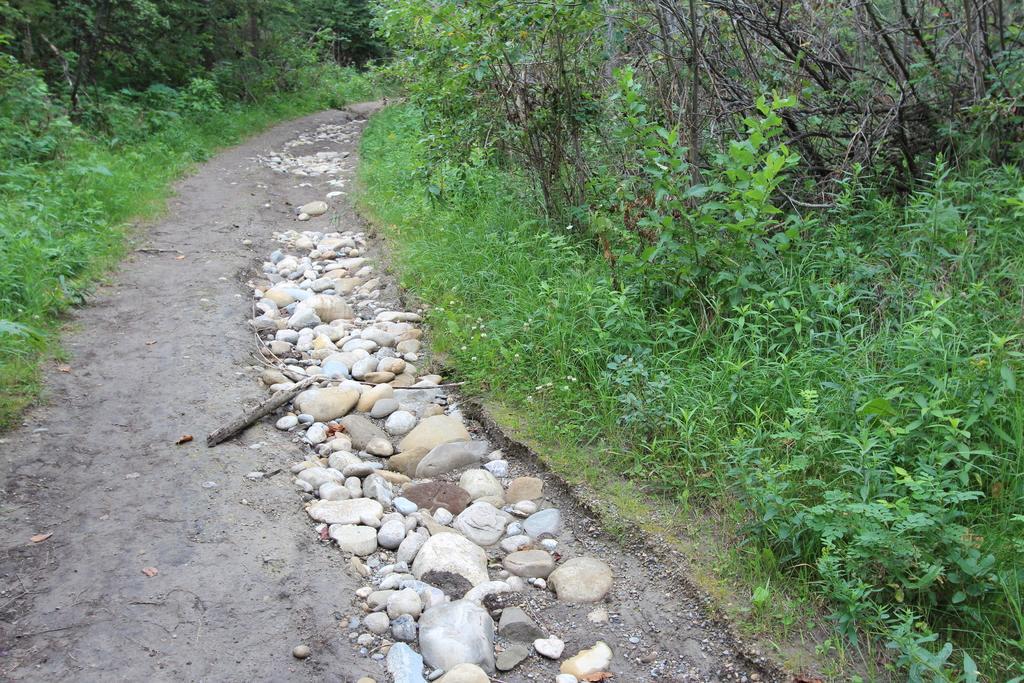In one or two sentences, can you explain what this image depicts? In this image, we can see a way and there are some green plants and trees. 